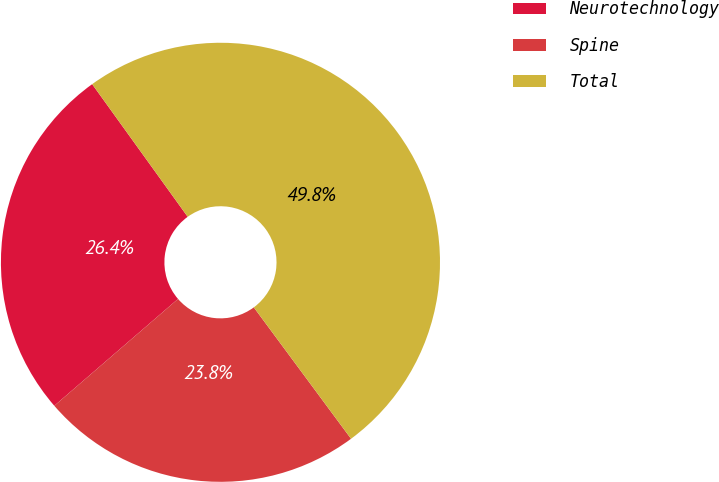<chart> <loc_0><loc_0><loc_500><loc_500><pie_chart><fcel>Neurotechnology<fcel>Spine<fcel>Total<nl><fcel>26.4%<fcel>23.8%<fcel>49.79%<nl></chart> 